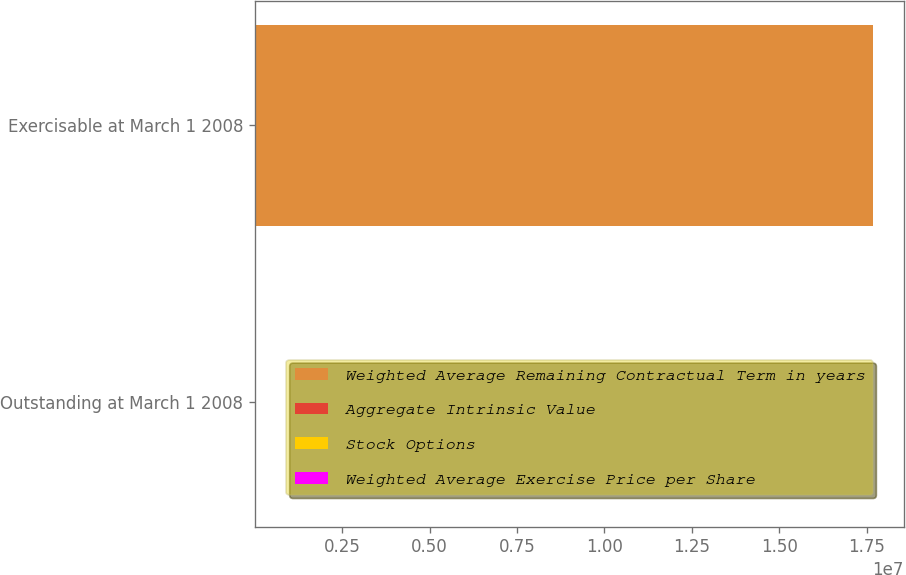Convert chart. <chart><loc_0><loc_0><loc_500><loc_500><stacked_bar_chart><ecel><fcel>Outstanding at March 1 2008<fcel>Exercisable at March 1 2008<nl><fcel>Weighted Average Remaining Contractual Term in years<fcel>39.73<fcel>1.7675e+07<nl><fcel>Aggregate Intrinsic Value<fcel>39.73<fcel>34<nl><fcel>Stock Options<fcel>6.35<fcel>4.8<nl><fcel>Weighted Average Exercise Price per Share<fcel>186<fcel>180<nl></chart> 